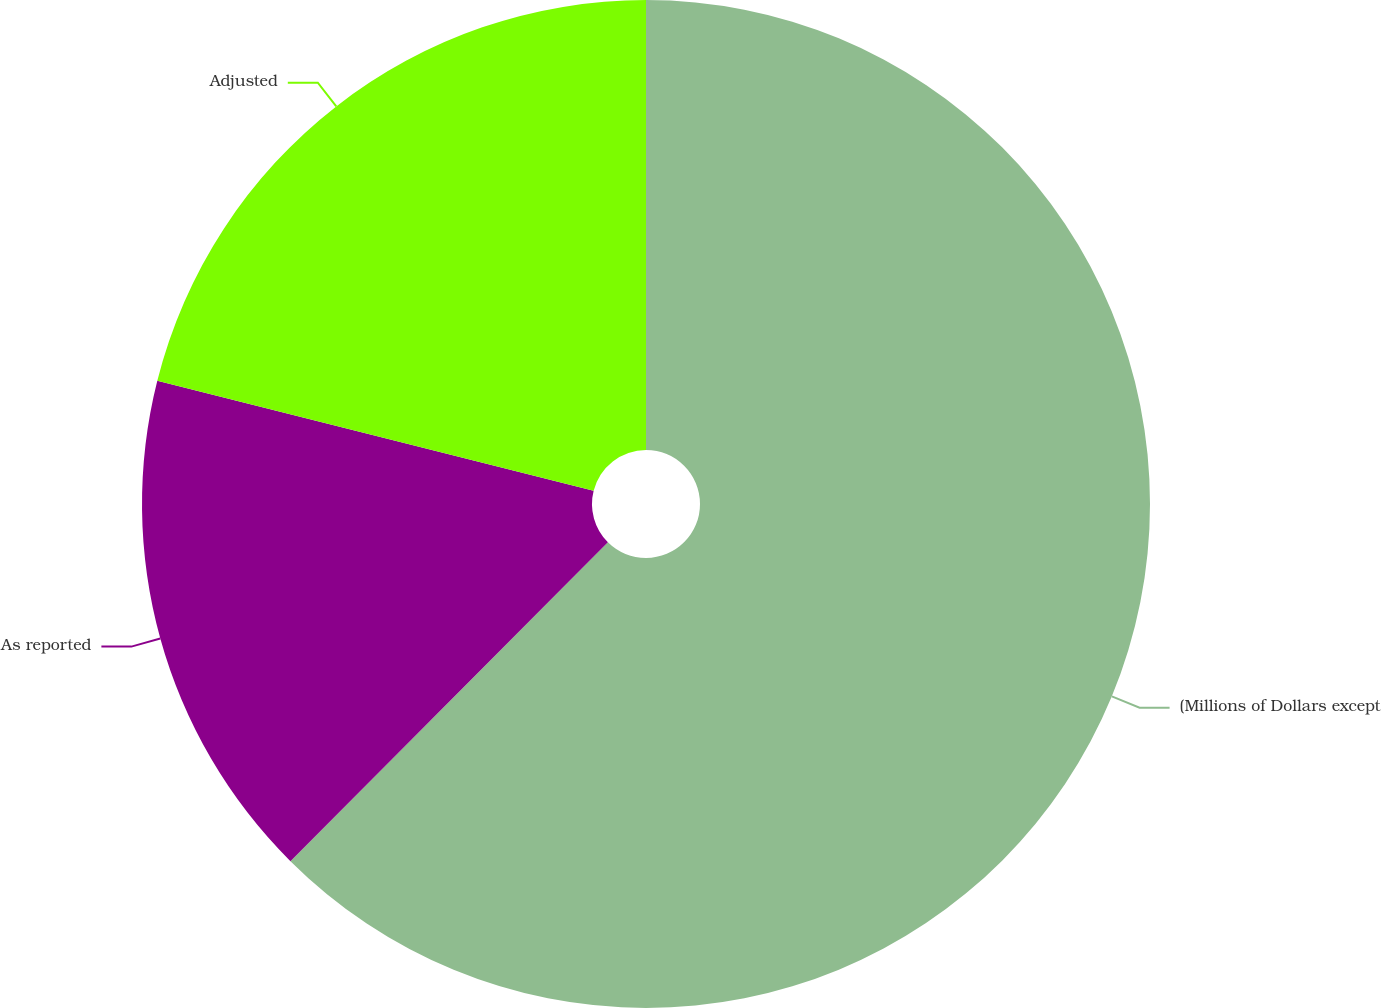Convert chart to OTSL. <chart><loc_0><loc_0><loc_500><loc_500><pie_chart><fcel>(Millions of Dollars except<fcel>As reported<fcel>Adjusted<nl><fcel>62.47%<fcel>16.47%<fcel>21.07%<nl></chart> 